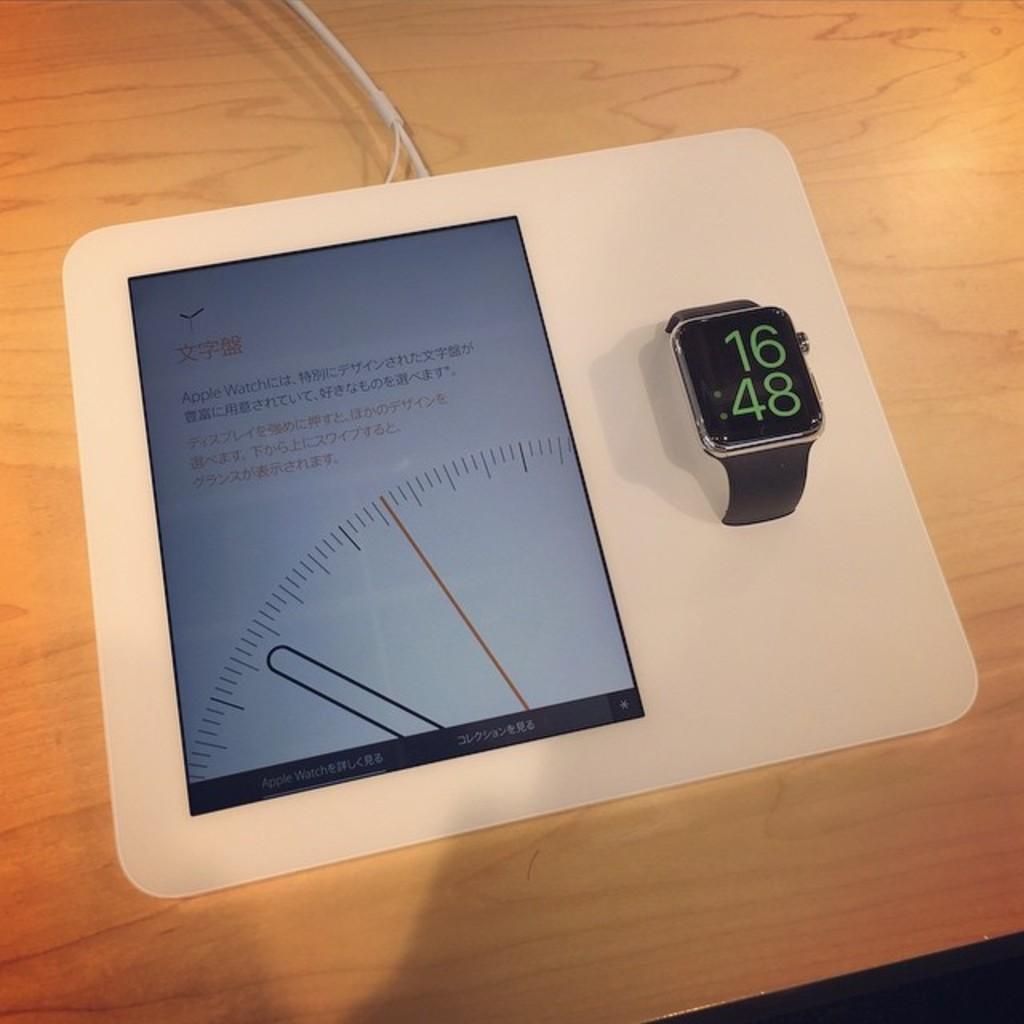What time is shown on the watch?
Offer a very short reply. 16:48. 